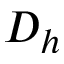<formula> <loc_0><loc_0><loc_500><loc_500>D _ { h }</formula> 